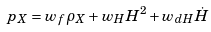<formula> <loc_0><loc_0><loc_500><loc_500>p _ { X } = w _ { f } \rho _ { X } + w _ { H } H ^ { 2 } + w _ { d H } \dot { H }</formula> 